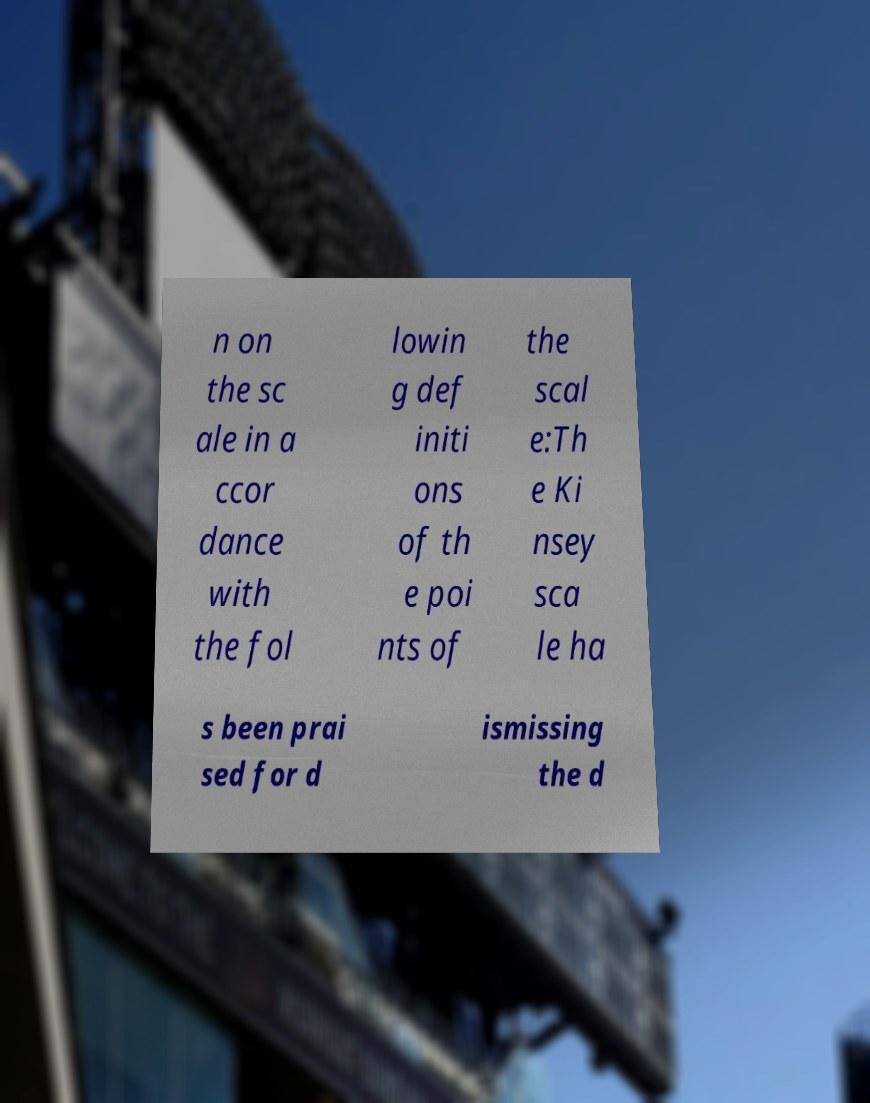Please identify and transcribe the text found in this image. n on the sc ale in a ccor dance with the fol lowin g def initi ons of th e poi nts of the scal e:Th e Ki nsey sca le ha s been prai sed for d ismissing the d 